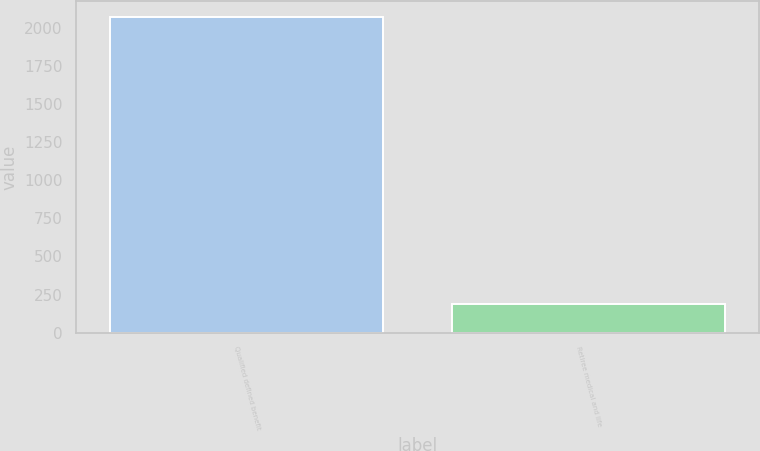<chart> <loc_0><loc_0><loc_500><loc_500><bar_chart><fcel>Qualified defined benefit<fcel>Retiree medical and life<nl><fcel>2070<fcel>190<nl></chart> 